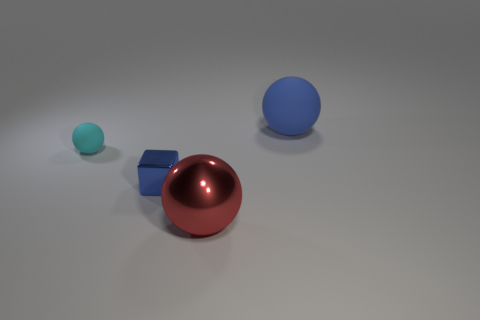Can you describe the colors and shapes of the objects in the image? Certainly! There are three objects in the image, each with a distinct color and shape. Closest to us is a small cyan sphere, followed by a medium-sized blue cube, and beyond them is a large, shiny red sphere. 